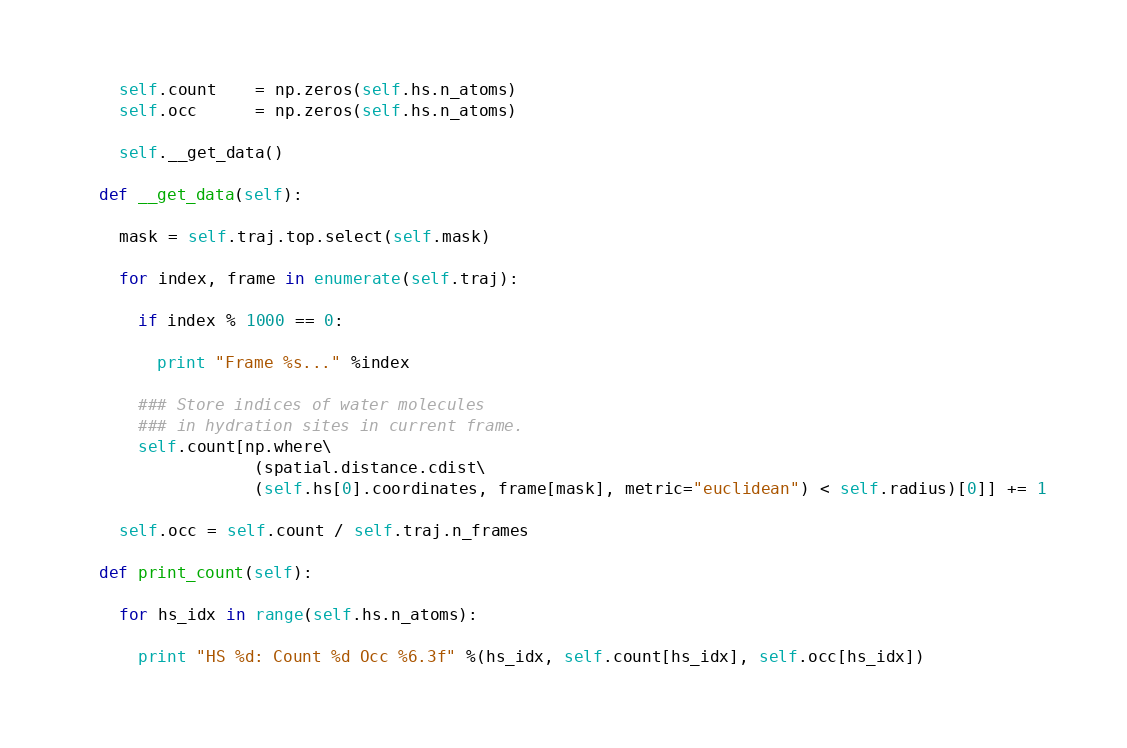<code> <loc_0><loc_0><loc_500><loc_500><_Python_>    self.count    = np.zeros(self.hs.n_atoms)
    self.occ      = np.zeros(self.hs.n_atoms)

    self.__get_data()

  def __get_data(self):

    mask = self.traj.top.select(self.mask)

    for index, frame in enumerate(self.traj):
  
      if index % 1000 == 0:

        print "Frame %s..." %index

      ### Store indices of water molecules
      ### in hydration sites in current frame. 
      self.count[np.where\
                  (spatial.distance.cdist\
                  (self.hs[0].coordinates, frame[mask], metric="euclidean") < self.radius)[0]] += 1

    self.occ = self.count / self.traj.n_frames

  def print_count(self):

    for hs_idx in range(self.hs.n_atoms):

      print "HS %d: Count %d Occ %6.3f" %(hs_idx, self.count[hs_idx], self.occ[hs_idx])
</code> 